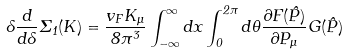<formula> <loc_0><loc_0><loc_500><loc_500>\Lambda \frac { d } { d \Lambda } \Sigma _ { 1 } ( K ) = \frac { v _ { F } K _ { \mu } } { 8 \pi ^ { 3 } } \int _ { - \infty } ^ { \infty } d x \int _ { 0 } ^ { 2 \pi } d \theta \frac { \partial F ( \hat { P } ) } { \partial P _ { \mu } } G ( \hat { P } )</formula> 